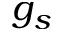Convert formula to latex. <formula><loc_0><loc_0><loc_500><loc_500>g _ { s }</formula> 